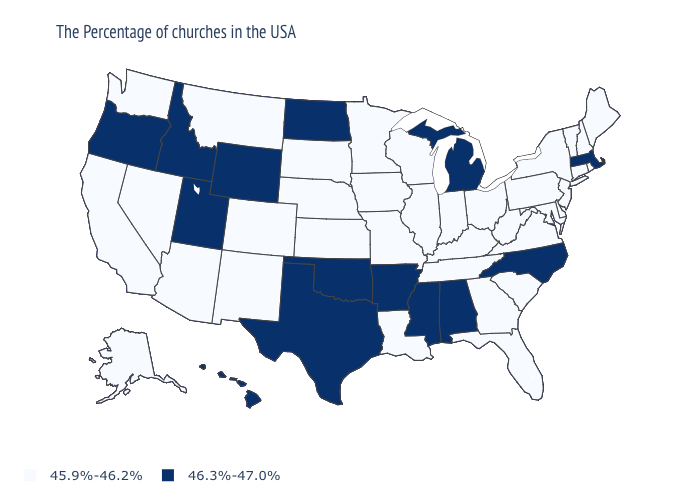What is the value of New Hampshire?
Write a very short answer. 45.9%-46.2%. What is the value of North Dakota?
Keep it brief. 46.3%-47.0%. Name the states that have a value in the range 45.9%-46.2%?
Quick response, please. Maine, Rhode Island, New Hampshire, Vermont, Connecticut, New York, New Jersey, Delaware, Maryland, Pennsylvania, Virginia, South Carolina, West Virginia, Ohio, Florida, Georgia, Kentucky, Indiana, Tennessee, Wisconsin, Illinois, Louisiana, Missouri, Minnesota, Iowa, Kansas, Nebraska, South Dakota, Colorado, New Mexico, Montana, Arizona, Nevada, California, Washington, Alaska. How many symbols are there in the legend?
Quick response, please. 2. What is the value of Nevada?
Keep it brief. 45.9%-46.2%. How many symbols are there in the legend?
Give a very brief answer. 2. Does Rhode Island have a lower value than Maryland?
Give a very brief answer. No. Among the states that border New Mexico , which have the highest value?
Concise answer only. Oklahoma, Texas, Utah. What is the value of Ohio?
Quick response, please. 45.9%-46.2%. Which states have the lowest value in the Northeast?
Quick response, please. Maine, Rhode Island, New Hampshire, Vermont, Connecticut, New York, New Jersey, Pennsylvania. Does Vermont have a higher value than North Dakota?
Answer briefly. No. Does Maryland have the same value as Washington?
Quick response, please. Yes. Name the states that have a value in the range 46.3%-47.0%?
Concise answer only. Massachusetts, North Carolina, Michigan, Alabama, Mississippi, Arkansas, Oklahoma, Texas, North Dakota, Wyoming, Utah, Idaho, Oregon, Hawaii. Name the states that have a value in the range 45.9%-46.2%?
Concise answer only. Maine, Rhode Island, New Hampshire, Vermont, Connecticut, New York, New Jersey, Delaware, Maryland, Pennsylvania, Virginia, South Carolina, West Virginia, Ohio, Florida, Georgia, Kentucky, Indiana, Tennessee, Wisconsin, Illinois, Louisiana, Missouri, Minnesota, Iowa, Kansas, Nebraska, South Dakota, Colorado, New Mexico, Montana, Arizona, Nevada, California, Washington, Alaska. What is the value of West Virginia?
Write a very short answer. 45.9%-46.2%. 